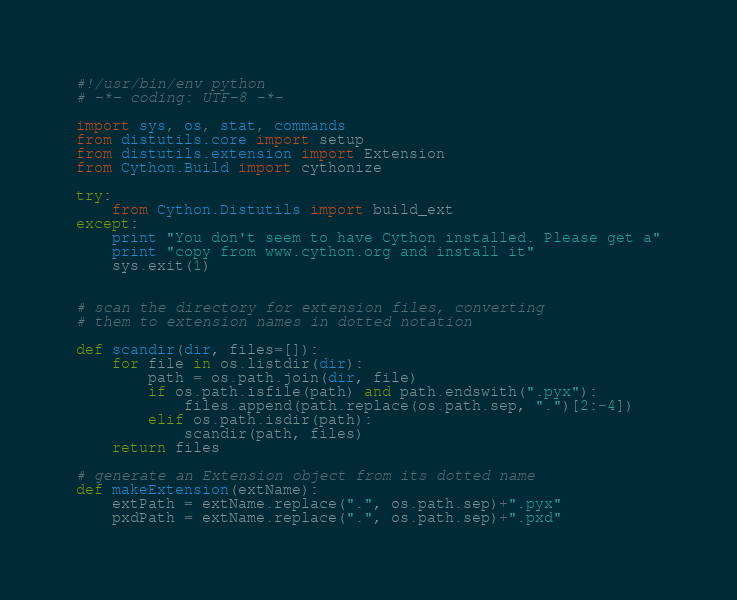Convert code to text. <code><loc_0><loc_0><loc_500><loc_500><_Python_>#!/usr/bin/env python
# -*- coding: UTF-8 -*-

import sys, os, stat, commands
from distutils.core import setup
from distutils.extension import Extension
from Cython.Build import cythonize

try:
    from Cython.Distutils import build_ext
except:
    print "You don't seem to have Cython installed. Please get a"
    print "copy from www.cython.org and install it"
    sys.exit(1)


# scan the directory for extension files, converting
# them to extension names in dotted notation

def scandir(dir, files=[]):
    for file in os.listdir(dir):
        path = os.path.join(dir, file)
        if os.path.isfile(path) and path.endswith(".pyx"):
            files.append(path.replace(os.path.sep, ".")[2:-4])
        elif os.path.isdir(path):
            scandir(path, files)
    return files

# generate an Extension object from its dotted name
def makeExtension(extName):
    extPath = extName.replace(".", os.path.sep)+".pyx"
    pxdPath = extName.replace(".", os.path.sep)+".pxd"</code> 